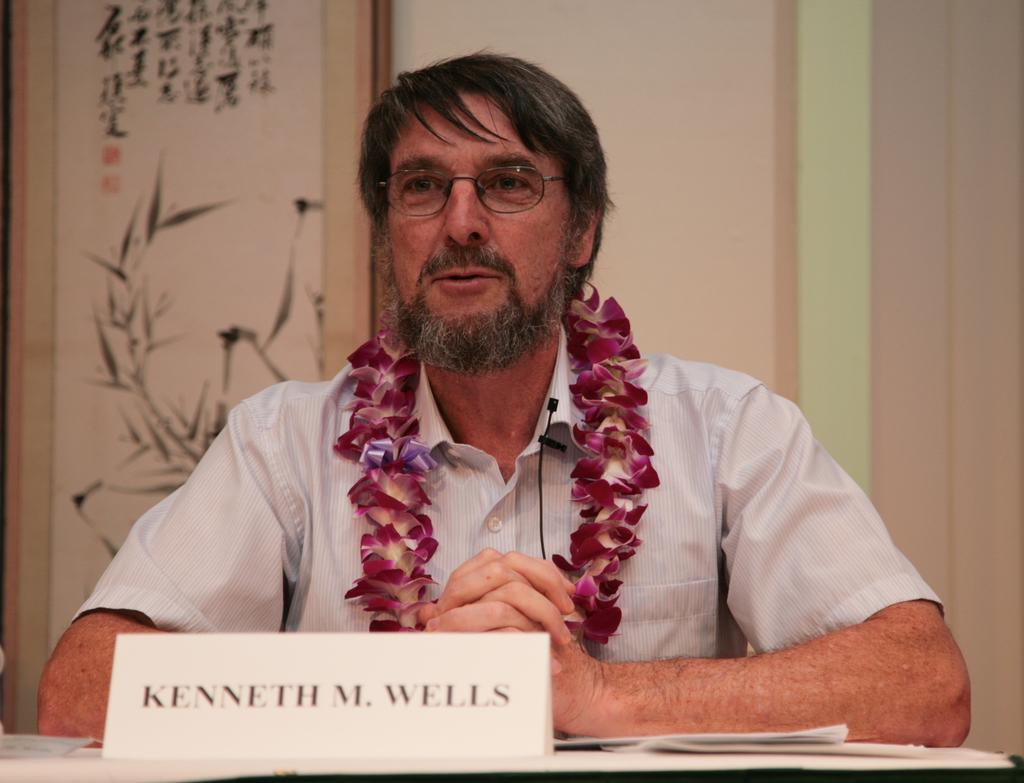Please provide a concise description of this image. In this image I can see a person wearing white shirt and glasses. I can see a table in front of him and on the table I can see a white colored board and few papers. I can see a flower garland on him and a black colored microphone to his shirt. In the background I can see the wall and a banner attached to the wall. 